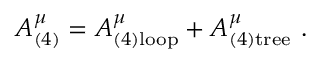Convert formula to latex. <formula><loc_0><loc_0><loc_500><loc_500>A _ { ( 4 ) } ^ { \mu } = A _ { ( 4 ) l o o p } ^ { \mu } + A _ { ( 4 ) t r e e } ^ { \mu } .</formula> 